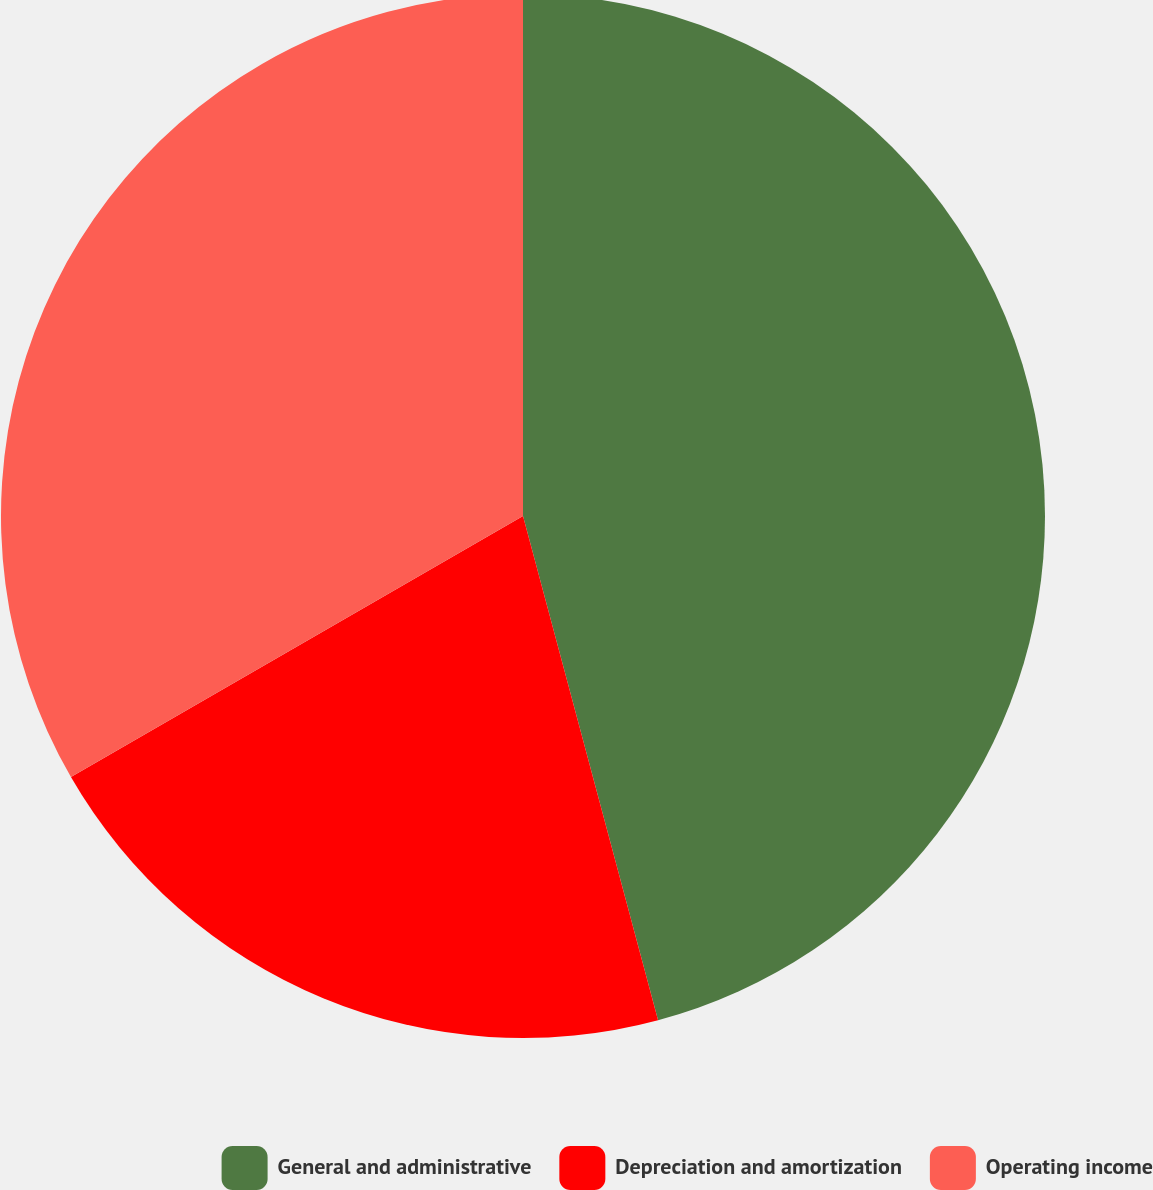<chart> <loc_0><loc_0><loc_500><loc_500><pie_chart><fcel>General and administrative<fcel>Depreciation and amortization<fcel>Operating income<nl><fcel>45.83%<fcel>20.83%<fcel>33.33%<nl></chart> 